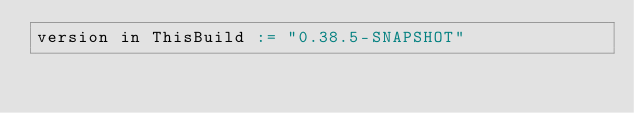Convert code to text. <code><loc_0><loc_0><loc_500><loc_500><_Scala_>version in ThisBuild := "0.38.5-SNAPSHOT"
</code> 